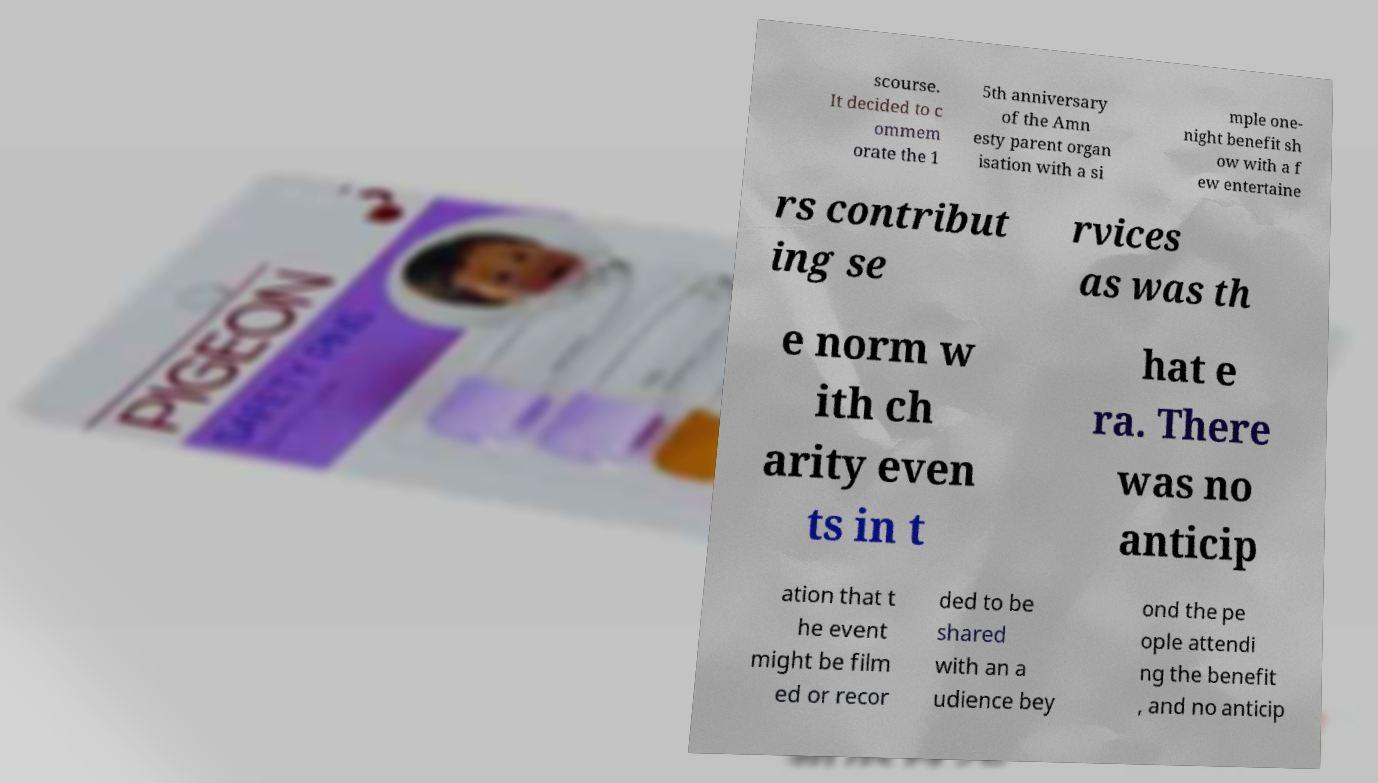There's text embedded in this image that I need extracted. Can you transcribe it verbatim? scourse. It decided to c ommem orate the 1 5th anniversary of the Amn esty parent organ isation with a si mple one- night benefit sh ow with a f ew entertaine rs contribut ing se rvices as was th e norm w ith ch arity even ts in t hat e ra. There was no anticip ation that t he event might be film ed or recor ded to be shared with an a udience bey ond the pe ople attendi ng the benefit , and no anticip 